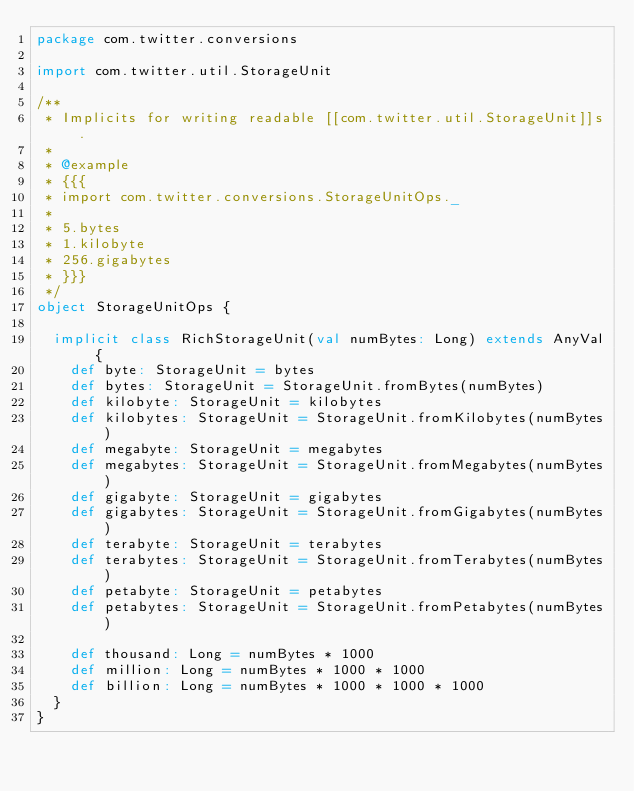Convert code to text. <code><loc_0><loc_0><loc_500><loc_500><_Scala_>package com.twitter.conversions

import com.twitter.util.StorageUnit

/**
 * Implicits for writing readable [[com.twitter.util.StorageUnit]]s.
 *
 * @example
 * {{{
 * import com.twitter.conversions.StorageUnitOps._
 *
 * 5.bytes
 * 1.kilobyte
 * 256.gigabytes
 * }}}
 */
object StorageUnitOps {

  implicit class RichStorageUnit(val numBytes: Long) extends AnyVal {
    def byte: StorageUnit = bytes
    def bytes: StorageUnit = StorageUnit.fromBytes(numBytes)
    def kilobyte: StorageUnit = kilobytes
    def kilobytes: StorageUnit = StorageUnit.fromKilobytes(numBytes)
    def megabyte: StorageUnit = megabytes
    def megabytes: StorageUnit = StorageUnit.fromMegabytes(numBytes)
    def gigabyte: StorageUnit = gigabytes
    def gigabytes: StorageUnit = StorageUnit.fromGigabytes(numBytes)
    def terabyte: StorageUnit = terabytes
    def terabytes: StorageUnit = StorageUnit.fromTerabytes(numBytes)
    def petabyte: StorageUnit = petabytes
    def petabytes: StorageUnit = StorageUnit.fromPetabytes(numBytes)

    def thousand: Long = numBytes * 1000
    def million: Long = numBytes * 1000 * 1000
    def billion: Long = numBytes * 1000 * 1000 * 1000
  }
}
</code> 